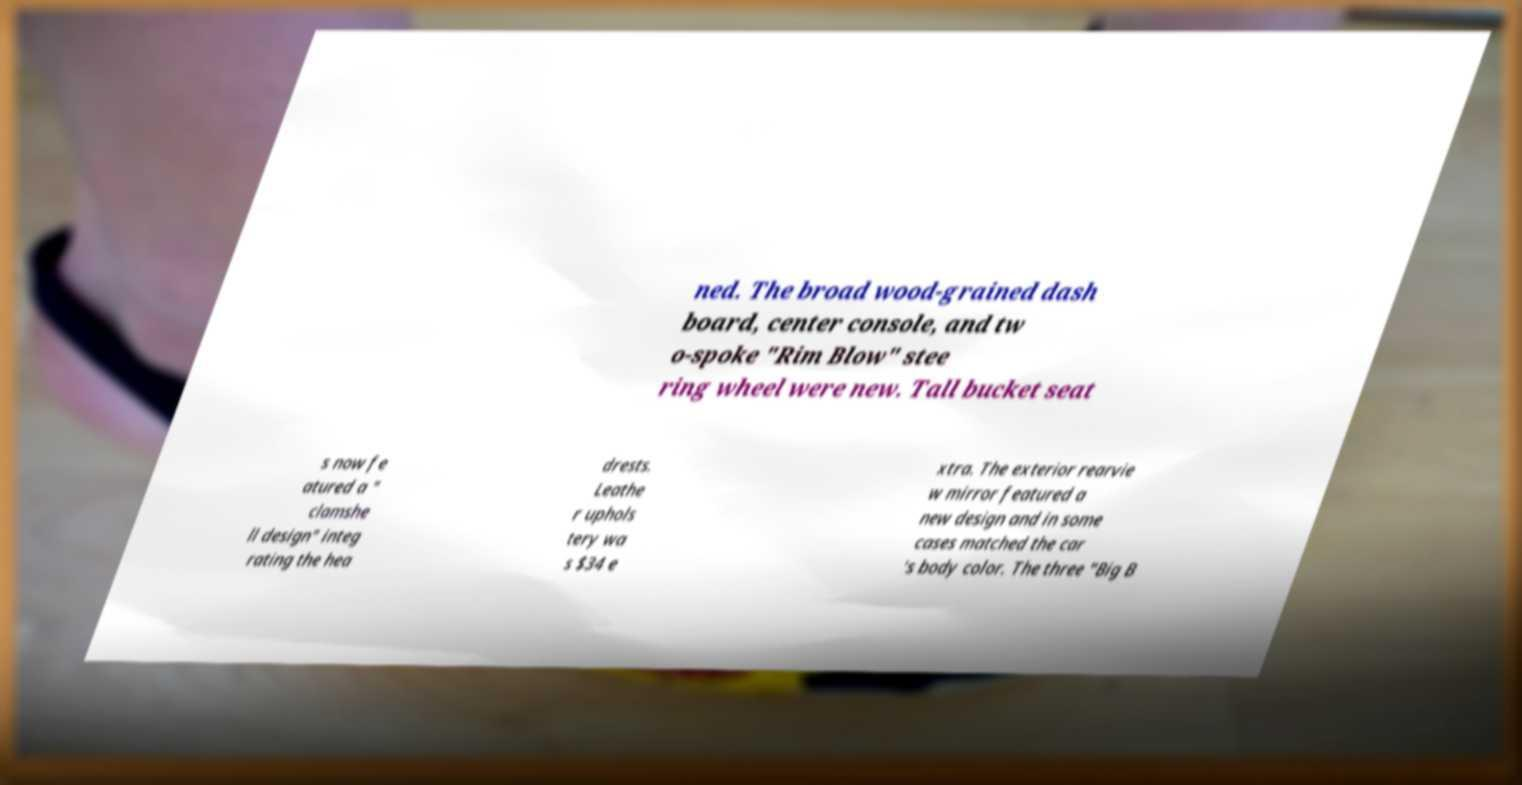For documentation purposes, I need the text within this image transcribed. Could you provide that? ned. The broad wood-grained dash board, center console, and tw o-spoke "Rim Blow" stee ring wheel were new. Tall bucket seat s now fe atured a " clamshe ll design" integ rating the hea drests. Leathe r uphols tery wa s $34 e xtra. The exterior rearvie w mirror featured a new design and in some cases matched the car 's body color. The three "Big B 